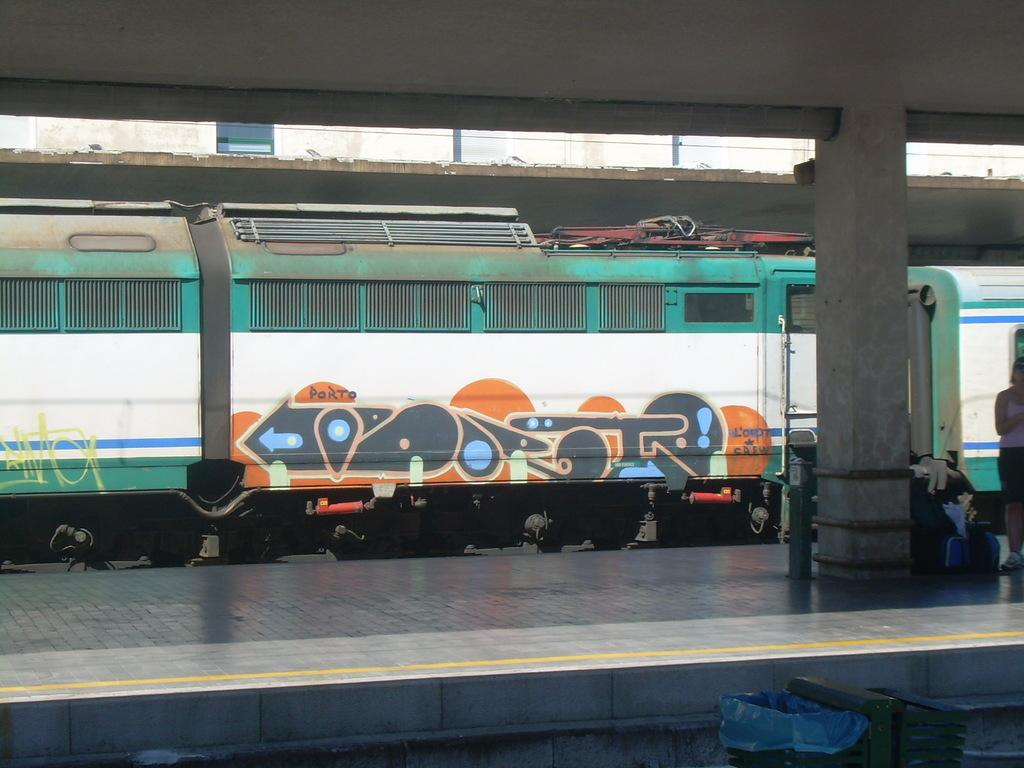What is there is a train in the image, what is it doing? The train is moving on a railway track in the image. What can be seen beside the train? There is a platform beside the train in the image. Who is present on the platform? A woman is standing on the platform in the image. What is the woman holding? The woman is holding luggage in the image. Can you see any sheep grazing in the wilderness near the train? There is no wilderness or sheep present in the image; it features a train moving on a railway track with a platform and a woman holding luggage. 